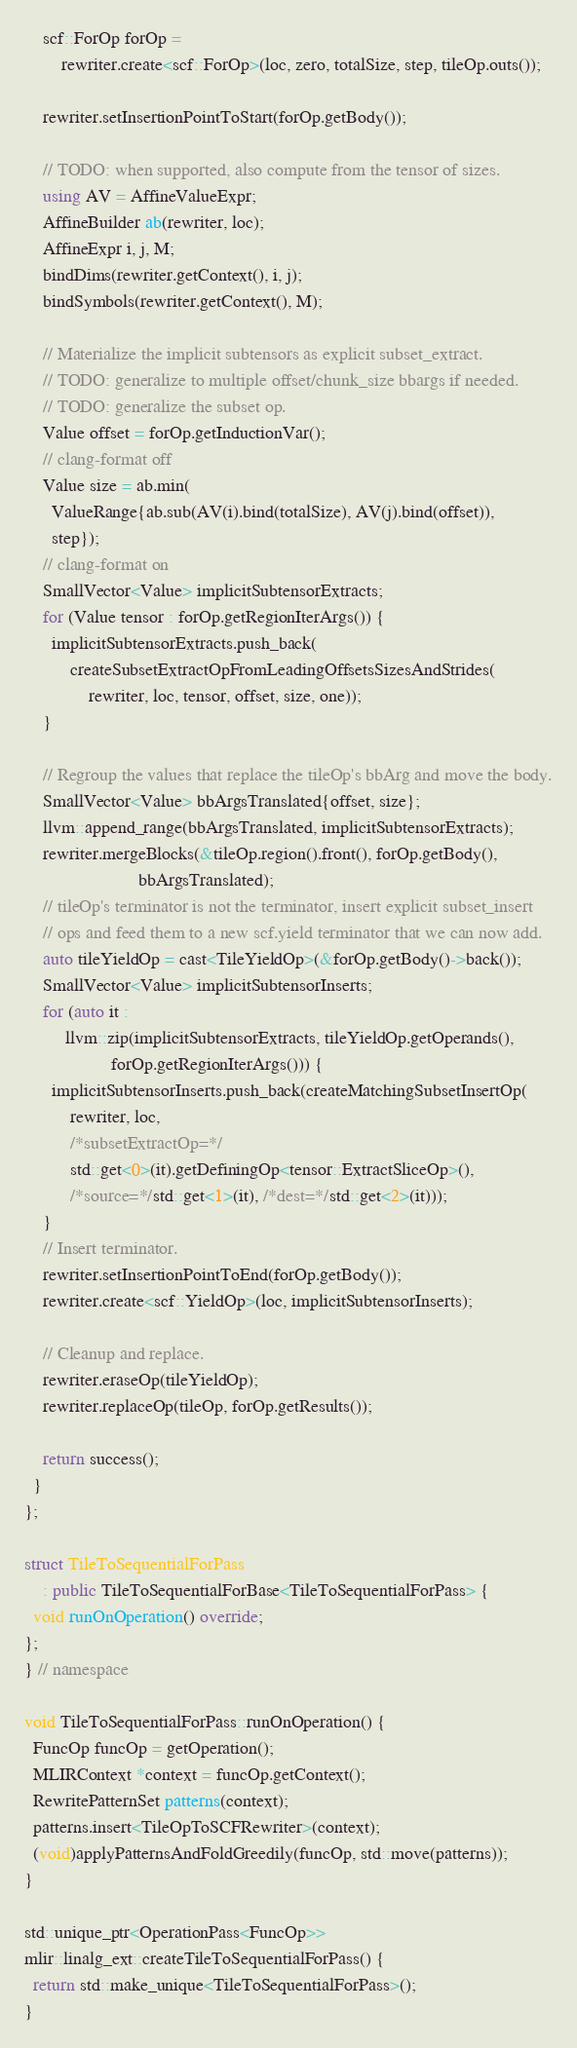<code> <loc_0><loc_0><loc_500><loc_500><_C++_>    scf::ForOp forOp =
        rewriter.create<scf::ForOp>(loc, zero, totalSize, step, tileOp.outs());

    rewriter.setInsertionPointToStart(forOp.getBody());

    // TODO: when supported, also compute from the tensor of sizes.
    using AV = AffineValueExpr;
    AffineBuilder ab(rewriter, loc);
    AffineExpr i, j, M;
    bindDims(rewriter.getContext(), i, j);
    bindSymbols(rewriter.getContext(), M);

    // Materialize the implicit subtensors as explicit subset_extract.
    // TODO: generalize to multiple offset/chunk_size bbargs if needed.
    // TODO: generalize the subset op.
    Value offset = forOp.getInductionVar();
    // clang-format off
    Value size = ab.min(
      ValueRange{ab.sub(AV(i).bind(totalSize), AV(j).bind(offset)),
      step});
    // clang-format on
    SmallVector<Value> implicitSubtensorExtracts;
    for (Value tensor : forOp.getRegionIterArgs()) {
      implicitSubtensorExtracts.push_back(
          createSubsetExtractOpFromLeadingOffsetsSizesAndStrides(
              rewriter, loc, tensor, offset, size, one));
    }

    // Regroup the values that replace the tileOp's bbArg and move the body.
    SmallVector<Value> bbArgsTranslated{offset, size};
    llvm::append_range(bbArgsTranslated, implicitSubtensorExtracts);
    rewriter.mergeBlocks(&tileOp.region().front(), forOp.getBody(),
                         bbArgsTranslated);
    // tileOp's terminator is not the terminator, insert explicit subset_insert
    // ops and feed them to a new scf.yield terminator that we can now add.
    auto tileYieldOp = cast<TileYieldOp>(&forOp.getBody()->back());
    SmallVector<Value> implicitSubtensorInserts;
    for (auto it :
         llvm::zip(implicitSubtensorExtracts, tileYieldOp.getOperands(),
                   forOp.getRegionIterArgs())) {
      implicitSubtensorInserts.push_back(createMatchingSubsetInsertOp(
          rewriter, loc,
          /*subsetExtractOp=*/
          std::get<0>(it).getDefiningOp<tensor::ExtractSliceOp>(),
          /*source=*/std::get<1>(it), /*dest=*/std::get<2>(it)));
    }
    // Insert terminator.
    rewriter.setInsertionPointToEnd(forOp.getBody());
    rewriter.create<scf::YieldOp>(loc, implicitSubtensorInserts);

    // Cleanup and replace.
    rewriter.eraseOp(tileYieldOp);
    rewriter.replaceOp(tileOp, forOp.getResults());

    return success();
  }
};

struct TileToSequentialForPass
    : public TileToSequentialForBase<TileToSequentialForPass> {
  void runOnOperation() override;
};
} // namespace

void TileToSequentialForPass::runOnOperation() {
  FuncOp funcOp = getOperation();
  MLIRContext *context = funcOp.getContext();
  RewritePatternSet patterns(context);
  patterns.insert<TileOpToSCFRewriter>(context);
  (void)applyPatternsAndFoldGreedily(funcOp, std::move(patterns));
}

std::unique_ptr<OperationPass<FuncOp>>
mlir::linalg_ext::createTileToSequentialForPass() {
  return std::make_unique<TileToSequentialForPass>();
}
</code> 